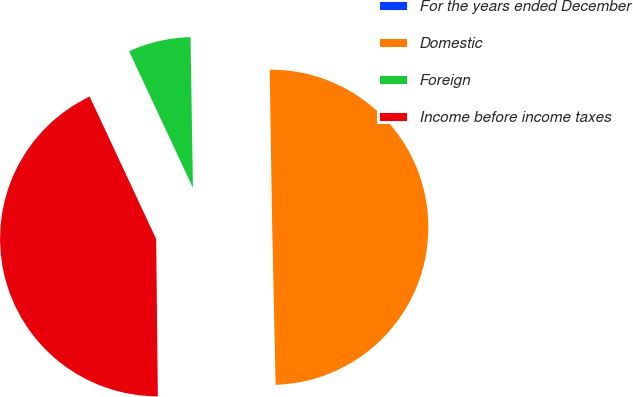Convert chart to OTSL. <chart><loc_0><loc_0><loc_500><loc_500><pie_chart><fcel>For the years ended December<fcel>Domestic<fcel>Foreign<fcel>Income before income taxes<nl><fcel>0.18%<fcel>49.91%<fcel>6.7%<fcel>43.21%<nl></chart> 